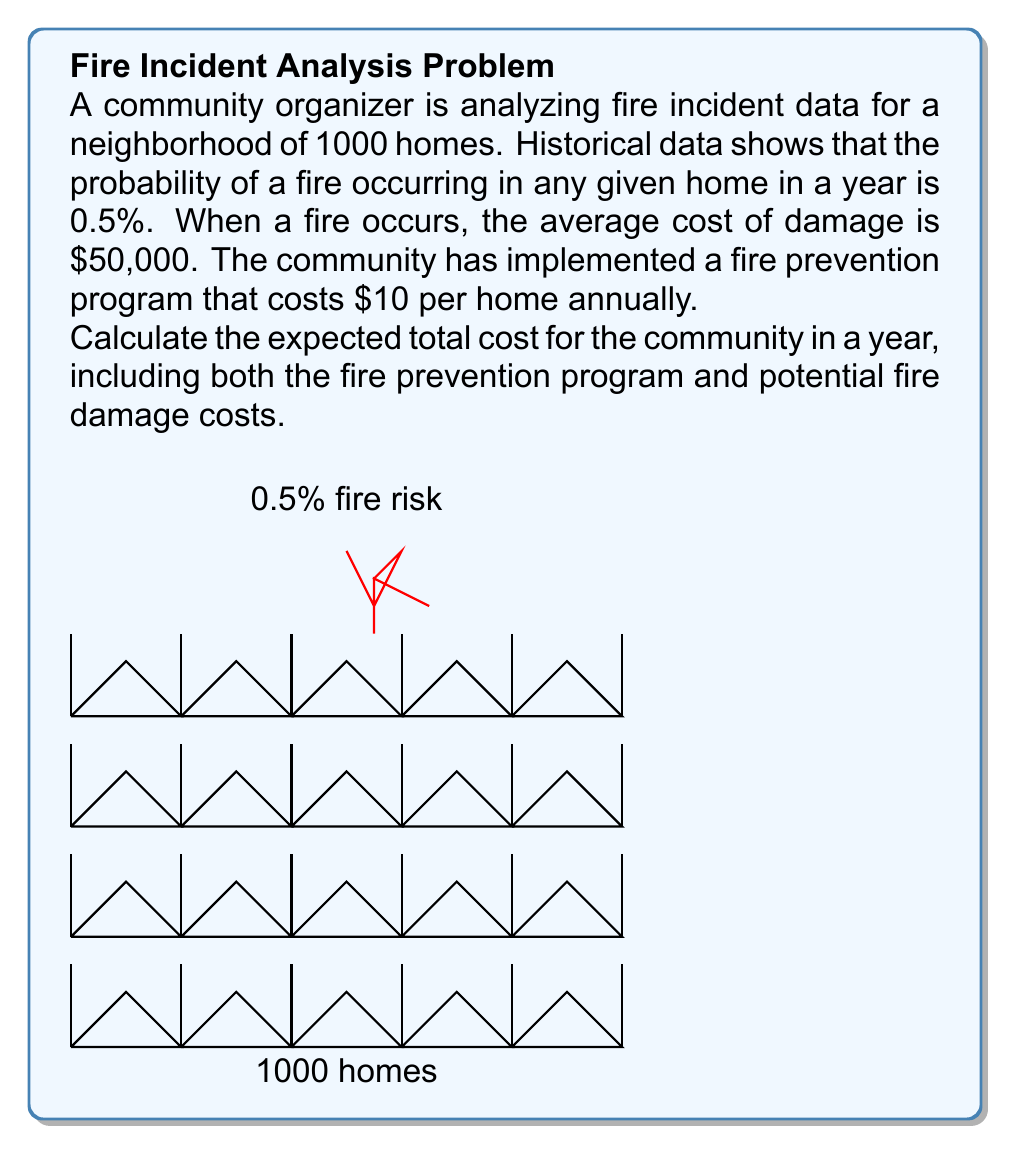Solve this math problem. Let's break this problem down step-by-step:

1) First, let's calculate the expected number of fires in a year:
   Number of homes = 1000
   Probability of fire per home = 0.5% = 0.005
   Expected number of fires = $1000 \times 0.005 = 5$ fires

2) Now, let's calculate the expected cost of fire damage:
   Expected number of fires = 5
   Average cost per fire = $50,000
   Expected cost of fire damage = $5 \times \$50,000 = \$250,000$

3) Next, let's calculate the cost of the fire prevention program:
   Cost per home = $10
   Number of homes = 1000
   Total cost of prevention program = $1000 \times \$10 = \$10,000$

4) The total expected cost is the sum of the expected fire damage cost and the prevention program cost:
   Total expected cost = $\$250,000 + \$10,000 = \$260,000$

We can express this mathematically as:

$$E(\text{Total Cost}) = N \times p \times C + N \times P$$

Where:
$N$ = Number of homes (1000)
$p$ = Probability of fire per home (0.005)
$C$ = Average cost per fire ($50,000)
$P$ = Prevention program cost per home ($10)

$$E(\text{Total Cost}) = 1000 \times 0.005 \times \$50,000 + 1000 \times \$10 = \$260,000$$
Answer: $260,000 